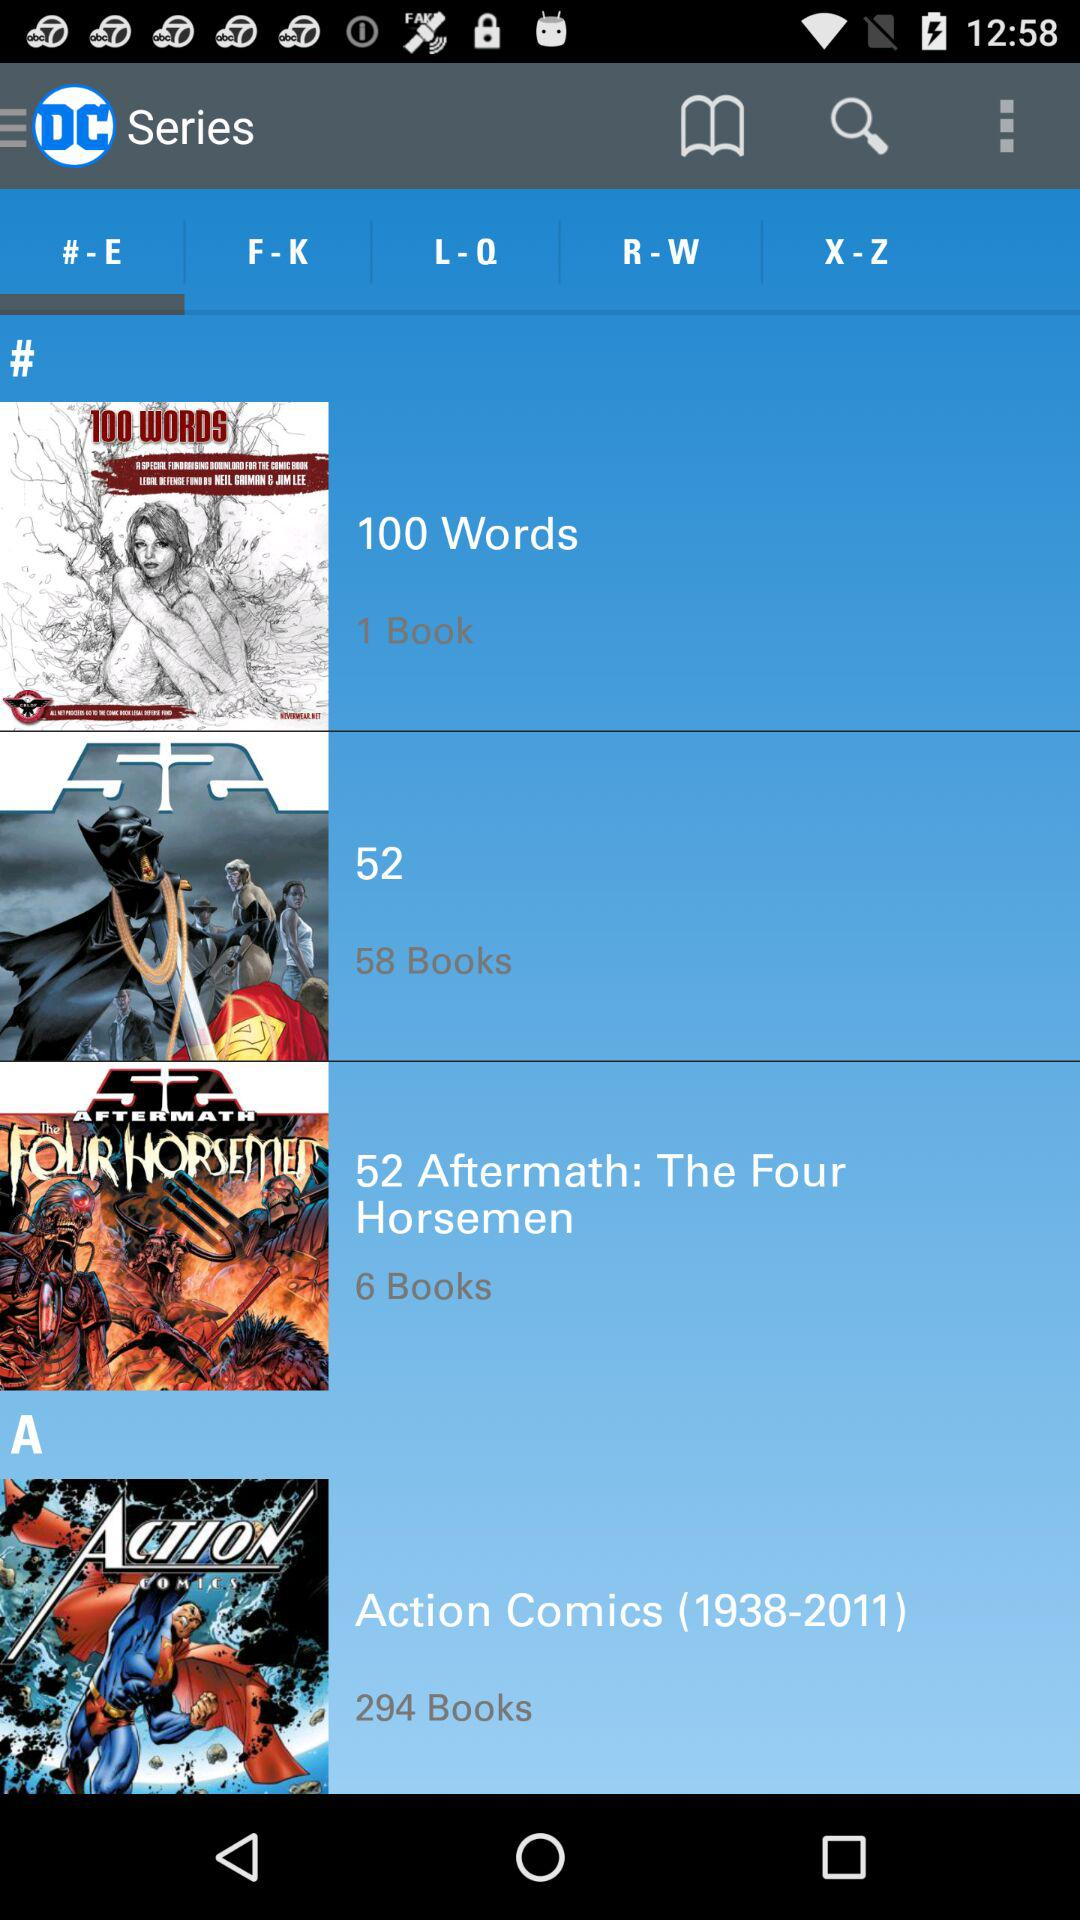Which option is selected in "Series"? The option that is selected in "Series" is "# - E". 